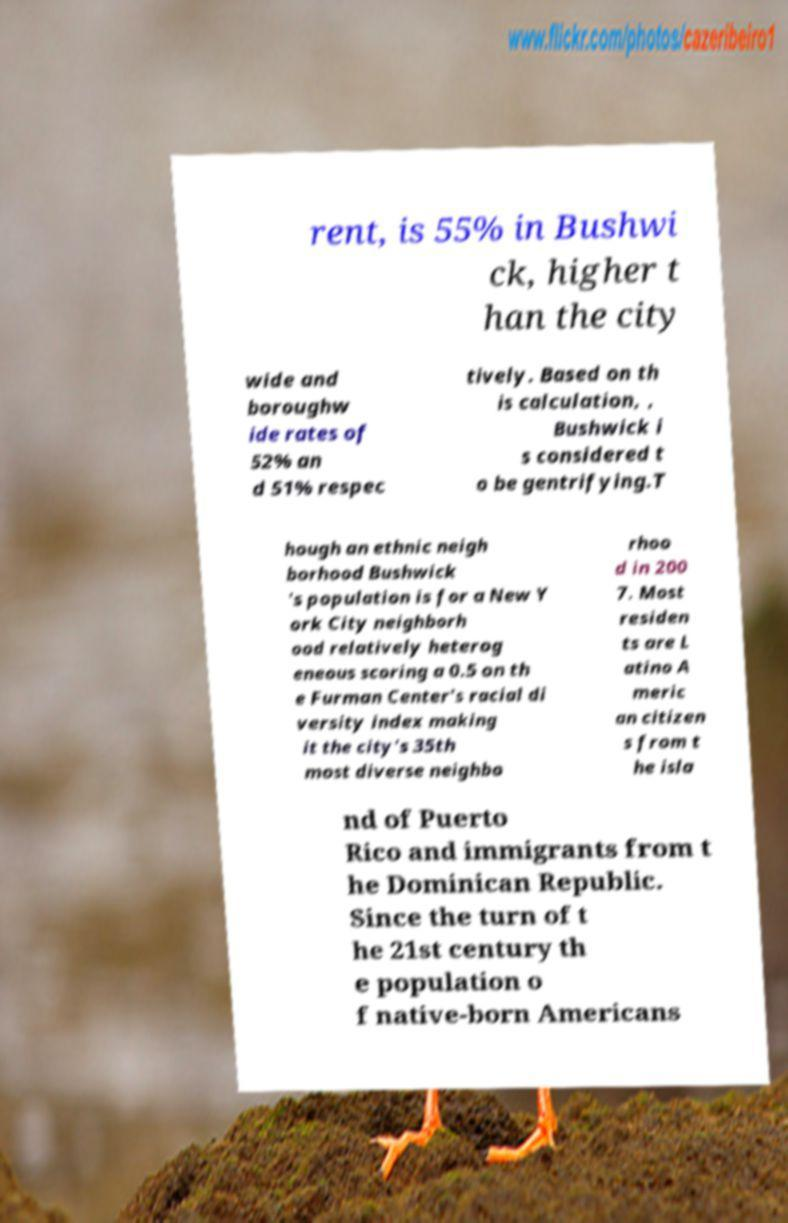Could you assist in decoding the text presented in this image and type it out clearly? rent, is 55% in Bushwi ck, higher t han the city wide and boroughw ide rates of 52% an d 51% respec tively. Based on th is calculation, , Bushwick i s considered t o be gentrifying.T hough an ethnic neigh borhood Bushwick 's population is for a New Y ork City neighborh ood relatively heterog eneous scoring a 0.5 on th e Furman Center's racial di versity index making it the city's 35th most diverse neighbo rhoo d in 200 7. Most residen ts are L atino A meric an citizen s from t he isla nd of Puerto Rico and immigrants from t he Dominican Republic. Since the turn of t he 21st century th e population o f native-born Americans 